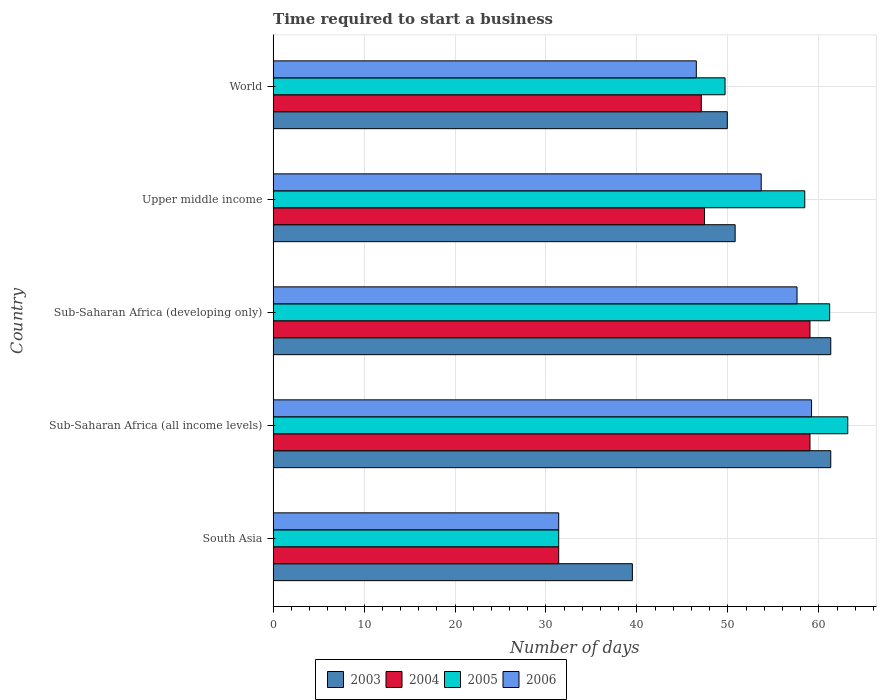How many different coloured bars are there?
Your answer should be compact. 4. How many groups of bars are there?
Offer a very short reply. 5. Are the number of bars per tick equal to the number of legend labels?
Provide a short and direct response. Yes. Are the number of bars on each tick of the Y-axis equal?
Keep it short and to the point. Yes. How many bars are there on the 4th tick from the bottom?
Offer a terse response. 4. What is the label of the 2nd group of bars from the top?
Offer a terse response. Upper middle income. What is the number of days required to start a business in 2006 in Sub-Saharan Africa (developing only)?
Offer a very short reply. 57.6. Across all countries, what is the maximum number of days required to start a business in 2005?
Offer a terse response. 63.18. Across all countries, what is the minimum number of days required to start a business in 2005?
Offer a terse response. 31.4. In which country was the number of days required to start a business in 2003 maximum?
Make the answer very short. Sub-Saharan Africa (all income levels). In which country was the number of days required to start a business in 2004 minimum?
Provide a short and direct response. South Asia. What is the total number of days required to start a business in 2006 in the graph?
Your response must be concise. 248.4. What is the difference between the number of days required to start a business in 2005 in Sub-Saharan Africa (all income levels) and that in Sub-Saharan Africa (developing only)?
Your response must be concise. 1.99. What is the difference between the number of days required to start a business in 2005 in Sub-Saharan Africa (all income levels) and the number of days required to start a business in 2006 in Upper middle income?
Offer a very short reply. 9.52. What is the average number of days required to start a business in 2003 per country?
Give a very brief answer. 52.57. What is the difference between the number of days required to start a business in 2005 and number of days required to start a business in 2003 in South Asia?
Make the answer very short. -8.1. What is the ratio of the number of days required to start a business in 2006 in South Asia to that in World?
Your answer should be compact. 0.67. Is the number of days required to start a business in 2006 in Sub-Saharan Africa (all income levels) less than that in Upper middle income?
Keep it short and to the point. No. What is the difference between the highest and the second highest number of days required to start a business in 2006?
Provide a short and direct response. 1.6. What is the difference between the highest and the lowest number of days required to start a business in 2005?
Keep it short and to the point. 31.78. Is the sum of the number of days required to start a business in 2005 in South Asia and Upper middle income greater than the maximum number of days required to start a business in 2003 across all countries?
Provide a succinct answer. Yes. Is it the case that in every country, the sum of the number of days required to start a business in 2006 and number of days required to start a business in 2005 is greater than the sum of number of days required to start a business in 2004 and number of days required to start a business in 2003?
Provide a short and direct response. No. What does the 1st bar from the top in Upper middle income represents?
Make the answer very short. 2006. What does the 3rd bar from the bottom in South Asia represents?
Your answer should be very brief. 2005. How many countries are there in the graph?
Make the answer very short. 5. Does the graph contain grids?
Offer a very short reply. Yes. How are the legend labels stacked?
Give a very brief answer. Horizontal. What is the title of the graph?
Ensure brevity in your answer.  Time required to start a business. Does "1961" appear as one of the legend labels in the graph?
Ensure brevity in your answer.  No. What is the label or title of the X-axis?
Offer a very short reply. Number of days. What is the label or title of the Y-axis?
Your answer should be very brief. Country. What is the Number of days of 2003 in South Asia?
Give a very brief answer. 39.5. What is the Number of days of 2004 in South Asia?
Your answer should be very brief. 31.4. What is the Number of days in 2005 in South Asia?
Your response must be concise. 31.4. What is the Number of days in 2006 in South Asia?
Offer a terse response. 31.4. What is the Number of days of 2003 in Sub-Saharan Africa (all income levels)?
Your response must be concise. 61.31. What is the Number of days in 2004 in Sub-Saharan Africa (all income levels)?
Your response must be concise. 59.03. What is the Number of days of 2005 in Sub-Saharan Africa (all income levels)?
Provide a short and direct response. 63.18. What is the Number of days of 2006 in Sub-Saharan Africa (all income levels)?
Ensure brevity in your answer.  59.2. What is the Number of days of 2003 in Sub-Saharan Africa (developing only)?
Keep it short and to the point. 61.31. What is the Number of days in 2004 in Sub-Saharan Africa (developing only)?
Keep it short and to the point. 59.03. What is the Number of days in 2005 in Sub-Saharan Africa (developing only)?
Provide a succinct answer. 61.19. What is the Number of days of 2006 in Sub-Saharan Africa (developing only)?
Your answer should be compact. 57.6. What is the Number of days of 2003 in Upper middle income?
Give a very brief answer. 50.8. What is the Number of days of 2004 in Upper middle income?
Provide a short and direct response. 47.43. What is the Number of days of 2005 in Upper middle income?
Provide a short and direct response. 58.45. What is the Number of days of 2006 in Upper middle income?
Provide a succinct answer. 53.67. What is the Number of days of 2003 in World?
Your response must be concise. 49.94. What is the Number of days of 2004 in World?
Your response must be concise. 47.08. What is the Number of days of 2005 in World?
Ensure brevity in your answer.  49.69. What is the Number of days in 2006 in World?
Your response must be concise. 46.53. Across all countries, what is the maximum Number of days in 2003?
Provide a succinct answer. 61.31. Across all countries, what is the maximum Number of days in 2004?
Your answer should be very brief. 59.03. Across all countries, what is the maximum Number of days in 2005?
Provide a short and direct response. 63.18. Across all countries, what is the maximum Number of days of 2006?
Give a very brief answer. 59.2. Across all countries, what is the minimum Number of days of 2003?
Your response must be concise. 39.5. Across all countries, what is the minimum Number of days of 2004?
Make the answer very short. 31.4. Across all countries, what is the minimum Number of days of 2005?
Make the answer very short. 31.4. Across all countries, what is the minimum Number of days of 2006?
Provide a succinct answer. 31.4. What is the total Number of days of 2003 in the graph?
Give a very brief answer. 262.86. What is the total Number of days of 2004 in the graph?
Your answer should be very brief. 243.97. What is the total Number of days in 2005 in the graph?
Your answer should be compact. 263.92. What is the total Number of days in 2006 in the graph?
Provide a short and direct response. 248.4. What is the difference between the Number of days in 2003 in South Asia and that in Sub-Saharan Africa (all income levels)?
Ensure brevity in your answer.  -21.81. What is the difference between the Number of days in 2004 in South Asia and that in Sub-Saharan Africa (all income levels)?
Give a very brief answer. -27.63. What is the difference between the Number of days in 2005 in South Asia and that in Sub-Saharan Africa (all income levels)?
Offer a very short reply. -31.78. What is the difference between the Number of days in 2006 in South Asia and that in Sub-Saharan Africa (all income levels)?
Make the answer very short. -27.8. What is the difference between the Number of days of 2003 in South Asia and that in Sub-Saharan Africa (developing only)?
Give a very brief answer. -21.81. What is the difference between the Number of days in 2004 in South Asia and that in Sub-Saharan Africa (developing only)?
Ensure brevity in your answer.  -27.63. What is the difference between the Number of days in 2005 in South Asia and that in Sub-Saharan Africa (developing only)?
Offer a terse response. -29.79. What is the difference between the Number of days in 2006 in South Asia and that in Sub-Saharan Africa (developing only)?
Give a very brief answer. -26.2. What is the difference between the Number of days in 2003 in South Asia and that in Upper middle income?
Your response must be concise. -11.3. What is the difference between the Number of days in 2004 in South Asia and that in Upper middle income?
Your response must be concise. -16.03. What is the difference between the Number of days in 2005 in South Asia and that in Upper middle income?
Offer a terse response. -27.05. What is the difference between the Number of days in 2006 in South Asia and that in Upper middle income?
Keep it short and to the point. -22.27. What is the difference between the Number of days in 2003 in South Asia and that in World?
Make the answer very short. -10.44. What is the difference between the Number of days of 2004 in South Asia and that in World?
Your answer should be compact. -15.68. What is the difference between the Number of days in 2005 in South Asia and that in World?
Your answer should be compact. -18.29. What is the difference between the Number of days of 2006 in South Asia and that in World?
Your answer should be very brief. -15.13. What is the difference between the Number of days in 2003 in Sub-Saharan Africa (all income levels) and that in Sub-Saharan Africa (developing only)?
Your response must be concise. 0. What is the difference between the Number of days of 2005 in Sub-Saharan Africa (all income levels) and that in Sub-Saharan Africa (developing only)?
Provide a succinct answer. 1.99. What is the difference between the Number of days of 2006 in Sub-Saharan Africa (all income levels) and that in Sub-Saharan Africa (developing only)?
Your answer should be very brief. 1.6. What is the difference between the Number of days in 2003 in Sub-Saharan Africa (all income levels) and that in Upper middle income?
Ensure brevity in your answer.  10.51. What is the difference between the Number of days in 2004 in Sub-Saharan Africa (all income levels) and that in Upper middle income?
Your answer should be compact. 11.6. What is the difference between the Number of days of 2005 in Sub-Saharan Africa (all income levels) and that in Upper middle income?
Make the answer very short. 4.73. What is the difference between the Number of days in 2006 in Sub-Saharan Africa (all income levels) and that in Upper middle income?
Keep it short and to the point. 5.53. What is the difference between the Number of days of 2003 in Sub-Saharan Africa (all income levels) and that in World?
Make the answer very short. 11.38. What is the difference between the Number of days in 2004 in Sub-Saharan Africa (all income levels) and that in World?
Offer a terse response. 11.95. What is the difference between the Number of days of 2005 in Sub-Saharan Africa (all income levels) and that in World?
Provide a succinct answer. 13.49. What is the difference between the Number of days in 2006 in Sub-Saharan Africa (all income levels) and that in World?
Your response must be concise. 12.67. What is the difference between the Number of days in 2003 in Sub-Saharan Africa (developing only) and that in Upper middle income?
Your answer should be compact. 10.51. What is the difference between the Number of days of 2004 in Sub-Saharan Africa (developing only) and that in Upper middle income?
Ensure brevity in your answer.  11.6. What is the difference between the Number of days of 2005 in Sub-Saharan Africa (developing only) and that in Upper middle income?
Provide a succinct answer. 2.74. What is the difference between the Number of days in 2006 in Sub-Saharan Africa (developing only) and that in Upper middle income?
Offer a very short reply. 3.94. What is the difference between the Number of days in 2003 in Sub-Saharan Africa (developing only) and that in World?
Ensure brevity in your answer.  11.38. What is the difference between the Number of days of 2004 in Sub-Saharan Africa (developing only) and that in World?
Offer a terse response. 11.95. What is the difference between the Number of days in 2005 in Sub-Saharan Africa (developing only) and that in World?
Keep it short and to the point. 11.5. What is the difference between the Number of days in 2006 in Sub-Saharan Africa (developing only) and that in World?
Make the answer very short. 11.07. What is the difference between the Number of days in 2003 in Upper middle income and that in World?
Provide a succinct answer. 0.86. What is the difference between the Number of days of 2004 in Upper middle income and that in World?
Offer a terse response. 0.35. What is the difference between the Number of days in 2005 in Upper middle income and that in World?
Your answer should be compact. 8.76. What is the difference between the Number of days in 2006 in Upper middle income and that in World?
Offer a terse response. 7.14. What is the difference between the Number of days in 2003 in South Asia and the Number of days in 2004 in Sub-Saharan Africa (all income levels)?
Offer a terse response. -19.53. What is the difference between the Number of days in 2003 in South Asia and the Number of days in 2005 in Sub-Saharan Africa (all income levels)?
Offer a terse response. -23.68. What is the difference between the Number of days in 2003 in South Asia and the Number of days in 2006 in Sub-Saharan Africa (all income levels)?
Provide a short and direct response. -19.7. What is the difference between the Number of days of 2004 in South Asia and the Number of days of 2005 in Sub-Saharan Africa (all income levels)?
Keep it short and to the point. -31.78. What is the difference between the Number of days of 2004 in South Asia and the Number of days of 2006 in Sub-Saharan Africa (all income levels)?
Make the answer very short. -27.8. What is the difference between the Number of days in 2005 in South Asia and the Number of days in 2006 in Sub-Saharan Africa (all income levels)?
Your response must be concise. -27.8. What is the difference between the Number of days of 2003 in South Asia and the Number of days of 2004 in Sub-Saharan Africa (developing only)?
Ensure brevity in your answer.  -19.53. What is the difference between the Number of days of 2003 in South Asia and the Number of days of 2005 in Sub-Saharan Africa (developing only)?
Your response must be concise. -21.69. What is the difference between the Number of days of 2003 in South Asia and the Number of days of 2006 in Sub-Saharan Africa (developing only)?
Your answer should be compact. -18.1. What is the difference between the Number of days of 2004 in South Asia and the Number of days of 2005 in Sub-Saharan Africa (developing only)?
Make the answer very short. -29.79. What is the difference between the Number of days of 2004 in South Asia and the Number of days of 2006 in Sub-Saharan Africa (developing only)?
Ensure brevity in your answer.  -26.2. What is the difference between the Number of days of 2005 in South Asia and the Number of days of 2006 in Sub-Saharan Africa (developing only)?
Make the answer very short. -26.2. What is the difference between the Number of days of 2003 in South Asia and the Number of days of 2004 in Upper middle income?
Your answer should be compact. -7.93. What is the difference between the Number of days in 2003 in South Asia and the Number of days in 2005 in Upper middle income?
Give a very brief answer. -18.95. What is the difference between the Number of days of 2003 in South Asia and the Number of days of 2006 in Upper middle income?
Keep it short and to the point. -14.17. What is the difference between the Number of days in 2004 in South Asia and the Number of days in 2005 in Upper middle income?
Give a very brief answer. -27.05. What is the difference between the Number of days of 2004 in South Asia and the Number of days of 2006 in Upper middle income?
Give a very brief answer. -22.27. What is the difference between the Number of days of 2005 in South Asia and the Number of days of 2006 in Upper middle income?
Provide a short and direct response. -22.27. What is the difference between the Number of days in 2003 in South Asia and the Number of days in 2004 in World?
Provide a succinct answer. -7.58. What is the difference between the Number of days of 2003 in South Asia and the Number of days of 2005 in World?
Your response must be concise. -10.19. What is the difference between the Number of days of 2003 in South Asia and the Number of days of 2006 in World?
Your answer should be compact. -7.03. What is the difference between the Number of days in 2004 in South Asia and the Number of days in 2005 in World?
Offer a terse response. -18.29. What is the difference between the Number of days of 2004 in South Asia and the Number of days of 2006 in World?
Keep it short and to the point. -15.13. What is the difference between the Number of days in 2005 in South Asia and the Number of days in 2006 in World?
Make the answer very short. -15.13. What is the difference between the Number of days of 2003 in Sub-Saharan Africa (all income levels) and the Number of days of 2004 in Sub-Saharan Africa (developing only)?
Your answer should be very brief. 2.28. What is the difference between the Number of days in 2003 in Sub-Saharan Africa (all income levels) and the Number of days in 2005 in Sub-Saharan Africa (developing only)?
Your answer should be compact. 0.12. What is the difference between the Number of days in 2003 in Sub-Saharan Africa (all income levels) and the Number of days in 2006 in Sub-Saharan Africa (developing only)?
Your answer should be compact. 3.71. What is the difference between the Number of days of 2004 in Sub-Saharan Africa (all income levels) and the Number of days of 2005 in Sub-Saharan Africa (developing only)?
Provide a succinct answer. -2.16. What is the difference between the Number of days of 2004 in Sub-Saharan Africa (all income levels) and the Number of days of 2006 in Sub-Saharan Africa (developing only)?
Your response must be concise. 1.42. What is the difference between the Number of days of 2005 in Sub-Saharan Africa (all income levels) and the Number of days of 2006 in Sub-Saharan Africa (developing only)?
Give a very brief answer. 5.58. What is the difference between the Number of days of 2003 in Sub-Saharan Africa (all income levels) and the Number of days of 2004 in Upper middle income?
Offer a terse response. 13.88. What is the difference between the Number of days in 2003 in Sub-Saharan Africa (all income levels) and the Number of days in 2005 in Upper middle income?
Offer a terse response. 2.86. What is the difference between the Number of days of 2003 in Sub-Saharan Africa (all income levels) and the Number of days of 2006 in Upper middle income?
Keep it short and to the point. 7.65. What is the difference between the Number of days of 2004 in Sub-Saharan Africa (all income levels) and the Number of days of 2005 in Upper middle income?
Provide a short and direct response. 0.57. What is the difference between the Number of days of 2004 in Sub-Saharan Africa (all income levels) and the Number of days of 2006 in Upper middle income?
Provide a short and direct response. 5.36. What is the difference between the Number of days of 2005 in Sub-Saharan Africa (all income levels) and the Number of days of 2006 in Upper middle income?
Your response must be concise. 9.52. What is the difference between the Number of days of 2003 in Sub-Saharan Africa (all income levels) and the Number of days of 2004 in World?
Your answer should be very brief. 14.23. What is the difference between the Number of days in 2003 in Sub-Saharan Africa (all income levels) and the Number of days in 2005 in World?
Provide a short and direct response. 11.62. What is the difference between the Number of days of 2003 in Sub-Saharan Africa (all income levels) and the Number of days of 2006 in World?
Give a very brief answer. 14.78. What is the difference between the Number of days of 2004 in Sub-Saharan Africa (all income levels) and the Number of days of 2005 in World?
Offer a very short reply. 9.34. What is the difference between the Number of days in 2004 in Sub-Saharan Africa (all income levels) and the Number of days in 2006 in World?
Make the answer very short. 12.5. What is the difference between the Number of days in 2005 in Sub-Saharan Africa (all income levels) and the Number of days in 2006 in World?
Make the answer very short. 16.65. What is the difference between the Number of days in 2003 in Sub-Saharan Africa (developing only) and the Number of days in 2004 in Upper middle income?
Offer a very short reply. 13.88. What is the difference between the Number of days in 2003 in Sub-Saharan Africa (developing only) and the Number of days in 2005 in Upper middle income?
Your answer should be compact. 2.86. What is the difference between the Number of days in 2003 in Sub-Saharan Africa (developing only) and the Number of days in 2006 in Upper middle income?
Provide a short and direct response. 7.65. What is the difference between the Number of days of 2004 in Sub-Saharan Africa (developing only) and the Number of days of 2005 in Upper middle income?
Your answer should be compact. 0.57. What is the difference between the Number of days in 2004 in Sub-Saharan Africa (developing only) and the Number of days in 2006 in Upper middle income?
Your answer should be compact. 5.36. What is the difference between the Number of days of 2005 in Sub-Saharan Africa (developing only) and the Number of days of 2006 in Upper middle income?
Your answer should be very brief. 7.52. What is the difference between the Number of days of 2003 in Sub-Saharan Africa (developing only) and the Number of days of 2004 in World?
Provide a short and direct response. 14.23. What is the difference between the Number of days of 2003 in Sub-Saharan Africa (developing only) and the Number of days of 2005 in World?
Your answer should be compact. 11.62. What is the difference between the Number of days in 2003 in Sub-Saharan Africa (developing only) and the Number of days in 2006 in World?
Make the answer very short. 14.78. What is the difference between the Number of days in 2004 in Sub-Saharan Africa (developing only) and the Number of days in 2005 in World?
Provide a short and direct response. 9.34. What is the difference between the Number of days in 2004 in Sub-Saharan Africa (developing only) and the Number of days in 2006 in World?
Keep it short and to the point. 12.5. What is the difference between the Number of days of 2005 in Sub-Saharan Africa (developing only) and the Number of days of 2006 in World?
Your answer should be compact. 14.66. What is the difference between the Number of days of 2003 in Upper middle income and the Number of days of 2004 in World?
Offer a terse response. 3.72. What is the difference between the Number of days in 2003 in Upper middle income and the Number of days in 2005 in World?
Give a very brief answer. 1.11. What is the difference between the Number of days of 2003 in Upper middle income and the Number of days of 2006 in World?
Provide a short and direct response. 4.27. What is the difference between the Number of days of 2004 in Upper middle income and the Number of days of 2005 in World?
Keep it short and to the point. -2.26. What is the difference between the Number of days of 2004 in Upper middle income and the Number of days of 2006 in World?
Keep it short and to the point. 0.9. What is the difference between the Number of days of 2005 in Upper middle income and the Number of days of 2006 in World?
Keep it short and to the point. 11.92. What is the average Number of days of 2003 per country?
Offer a terse response. 52.57. What is the average Number of days in 2004 per country?
Your answer should be very brief. 48.79. What is the average Number of days in 2005 per country?
Offer a very short reply. 52.78. What is the average Number of days in 2006 per country?
Provide a succinct answer. 49.68. What is the difference between the Number of days in 2003 and Number of days in 2005 in South Asia?
Ensure brevity in your answer.  8.1. What is the difference between the Number of days in 2003 and Number of days in 2006 in South Asia?
Your answer should be very brief. 8.1. What is the difference between the Number of days of 2003 and Number of days of 2004 in Sub-Saharan Africa (all income levels)?
Provide a succinct answer. 2.28. What is the difference between the Number of days of 2003 and Number of days of 2005 in Sub-Saharan Africa (all income levels)?
Ensure brevity in your answer.  -1.87. What is the difference between the Number of days in 2003 and Number of days in 2006 in Sub-Saharan Africa (all income levels)?
Your answer should be very brief. 2.11. What is the difference between the Number of days in 2004 and Number of days in 2005 in Sub-Saharan Africa (all income levels)?
Your answer should be very brief. -4.15. What is the difference between the Number of days of 2004 and Number of days of 2006 in Sub-Saharan Africa (all income levels)?
Offer a very short reply. -0.17. What is the difference between the Number of days in 2005 and Number of days in 2006 in Sub-Saharan Africa (all income levels)?
Your answer should be very brief. 3.98. What is the difference between the Number of days of 2003 and Number of days of 2004 in Sub-Saharan Africa (developing only)?
Offer a very short reply. 2.28. What is the difference between the Number of days in 2003 and Number of days in 2005 in Sub-Saharan Africa (developing only)?
Your answer should be compact. 0.12. What is the difference between the Number of days of 2003 and Number of days of 2006 in Sub-Saharan Africa (developing only)?
Keep it short and to the point. 3.71. What is the difference between the Number of days in 2004 and Number of days in 2005 in Sub-Saharan Africa (developing only)?
Give a very brief answer. -2.16. What is the difference between the Number of days of 2004 and Number of days of 2006 in Sub-Saharan Africa (developing only)?
Keep it short and to the point. 1.42. What is the difference between the Number of days of 2005 and Number of days of 2006 in Sub-Saharan Africa (developing only)?
Your answer should be compact. 3.59. What is the difference between the Number of days in 2003 and Number of days in 2004 in Upper middle income?
Your response must be concise. 3.37. What is the difference between the Number of days of 2003 and Number of days of 2005 in Upper middle income?
Your answer should be very brief. -7.65. What is the difference between the Number of days in 2003 and Number of days in 2006 in Upper middle income?
Offer a very short reply. -2.87. What is the difference between the Number of days of 2004 and Number of days of 2005 in Upper middle income?
Offer a terse response. -11.02. What is the difference between the Number of days of 2004 and Number of days of 2006 in Upper middle income?
Give a very brief answer. -6.23. What is the difference between the Number of days in 2005 and Number of days in 2006 in Upper middle income?
Give a very brief answer. 4.79. What is the difference between the Number of days in 2003 and Number of days in 2004 in World?
Offer a terse response. 2.86. What is the difference between the Number of days of 2003 and Number of days of 2005 in World?
Offer a terse response. 0.25. What is the difference between the Number of days of 2003 and Number of days of 2006 in World?
Offer a terse response. 3.41. What is the difference between the Number of days in 2004 and Number of days in 2005 in World?
Offer a very short reply. -2.61. What is the difference between the Number of days of 2004 and Number of days of 2006 in World?
Give a very brief answer. 0.55. What is the difference between the Number of days in 2005 and Number of days in 2006 in World?
Your answer should be compact. 3.16. What is the ratio of the Number of days in 2003 in South Asia to that in Sub-Saharan Africa (all income levels)?
Your answer should be compact. 0.64. What is the ratio of the Number of days in 2004 in South Asia to that in Sub-Saharan Africa (all income levels)?
Provide a succinct answer. 0.53. What is the ratio of the Number of days of 2005 in South Asia to that in Sub-Saharan Africa (all income levels)?
Make the answer very short. 0.5. What is the ratio of the Number of days in 2006 in South Asia to that in Sub-Saharan Africa (all income levels)?
Your answer should be very brief. 0.53. What is the ratio of the Number of days of 2003 in South Asia to that in Sub-Saharan Africa (developing only)?
Ensure brevity in your answer.  0.64. What is the ratio of the Number of days of 2004 in South Asia to that in Sub-Saharan Africa (developing only)?
Make the answer very short. 0.53. What is the ratio of the Number of days of 2005 in South Asia to that in Sub-Saharan Africa (developing only)?
Your answer should be very brief. 0.51. What is the ratio of the Number of days in 2006 in South Asia to that in Sub-Saharan Africa (developing only)?
Make the answer very short. 0.55. What is the ratio of the Number of days in 2003 in South Asia to that in Upper middle income?
Provide a short and direct response. 0.78. What is the ratio of the Number of days of 2004 in South Asia to that in Upper middle income?
Offer a very short reply. 0.66. What is the ratio of the Number of days in 2005 in South Asia to that in Upper middle income?
Your answer should be compact. 0.54. What is the ratio of the Number of days of 2006 in South Asia to that in Upper middle income?
Your response must be concise. 0.59. What is the ratio of the Number of days in 2003 in South Asia to that in World?
Make the answer very short. 0.79. What is the ratio of the Number of days in 2004 in South Asia to that in World?
Ensure brevity in your answer.  0.67. What is the ratio of the Number of days of 2005 in South Asia to that in World?
Ensure brevity in your answer.  0.63. What is the ratio of the Number of days of 2006 in South Asia to that in World?
Give a very brief answer. 0.67. What is the ratio of the Number of days of 2005 in Sub-Saharan Africa (all income levels) to that in Sub-Saharan Africa (developing only)?
Ensure brevity in your answer.  1.03. What is the ratio of the Number of days of 2006 in Sub-Saharan Africa (all income levels) to that in Sub-Saharan Africa (developing only)?
Provide a short and direct response. 1.03. What is the ratio of the Number of days of 2003 in Sub-Saharan Africa (all income levels) to that in Upper middle income?
Your answer should be compact. 1.21. What is the ratio of the Number of days of 2004 in Sub-Saharan Africa (all income levels) to that in Upper middle income?
Provide a short and direct response. 1.24. What is the ratio of the Number of days in 2005 in Sub-Saharan Africa (all income levels) to that in Upper middle income?
Ensure brevity in your answer.  1.08. What is the ratio of the Number of days in 2006 in Sub-Saharan Africa (all income levels) to that in Upper middle income?
Provide a short and direct response. 1.1. What is the ratio of the Number of days in 2003 in Sub-Saharan Africa (all income levels) to that in World?
Give a very brief answer. 1.23. What is the ratio of the Number of days in 2004 in Sub-Saharan Africa (all income levels) to that in World?
Give a very brief answer. 1.25. What is the ratio of the Number of days in 2005 in Sub-Saharan Africa (all income levels) to that in World?
Your answer should be compact. 1.27. What is the ratio of the Number of days in 2006 in Sub-Saharan Africa (all income levels) to that in World?
Provide a succinct answer. 1.27. What is the ratio of the Number of days in 2003 in Sub-Saharan Africa (developing only) to that in Upper middle income?
Ensure brevity in your answer.  1.21. What is the ratio of the Number of days in 2004 in Sub-Saharan Africa (developing only) to that in Upper middle income?
Ensure brevity in your answer.  1.24. What is the ratio of the Number of days of 2005 in Sub-Saharan Africa (developing only) to that in Upper middle income?
Give a very brief answer. 1.05. What is the ratio of the Number of days in 2006 in Sub-Saharan Africa (developing only) to that in Upper middle income?
Provide a short and direct response. 1.07. What is the ratio of the Number of days of 2003 in Sub-Saharan Africa (developing only) to that in World?
Keep it short and to the point. 1.23. What is the ratio of the Number of days in 2004 in Sub-Saharan Africa (developing only) to that in World?
Offer a terse response. 1.25. What is the ratio of the Number of days of 2005 in Sub-Saharan Africa (developing only) to that in World?
Your answer should be very brief. 1.23. What is the ratio of the Number of days of 2006 in Sub-Saharan Africa (developing only) to that in World?
Your response must be concise. 1.24. What is the ratio of the Number of days of 2003 in Upper middle income to that in World?
Ensure brevity in your answer.  1.02. What is the ratio of the Number of days in 2004 in Upper middle income to that in World?
Provide a short and direct response. 1.01. What is the ratio of the Number of days of 2005 in Upper middle income to that in World?
Your answer should be very brief. 1.18. What is the ratio of the Number of days in 2006 in Upper middle income to that in World?
Ensure brevity in your answer.  1.15. What is the difference between the highest and the second highest Number of days in 2005?
Keep it short and to the point. 1.99. What is the difference between the highest and the second highest Number of days of 2006?
Give a very brief answer. 1.6. What is the difference between the highest and the lowest Number of days in 2003?
Provide a short and direct response. 21.81. What is the difference between the highest and the lowest Number of days of 2004?
Provide a succinct answer. 27.63. What is the difference between the highest and the lowest Number of days of 2005?
Give a very brief answer. 31.78. What is the difference between the highest and the lowest Number of days in 2006?
Give a very brief answer. 27.8. 